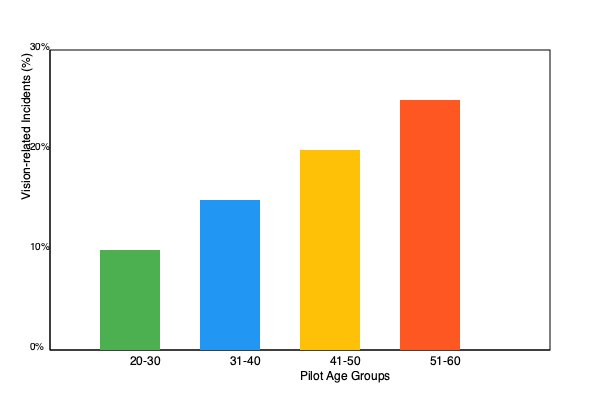Based on the bar graph showing the relationship between pilot age groups and vision-related incidents, which age group should be considered for higher insurance premiums or more frequent vision assessments? Provide a brief justification for your answer. To answer this question, we need to analyze the bar graph and interpret the data:

1. The graph shows four age groups of pilots: 20-30, 31-40, 41-50, and 51-60.
2. The y-axis represents the percentage of vision-related incidents.
3. We can observe that the percentage of vision-related incidents increases with age:
   - 20-30 age group: approximately 10%
   - 31-40 age group: approximately 15%
   - 41-50 age group: approximately 20%
   - 51-60 age group: approximately 25%
4. The 51-60 age group has the highest percentage of vision-related incidents at about 25%.
5. As an insurance professional, we should consider the group with the highest risk for higher premiums or more frequent assessments.
6. The data suggests that older pilots, particularly those in the 51-60 age group, are more prone to vision-related incidents.
7. This increased risk justifies considering higher insurance premiums or more frequent vision assessments for this age group.

Therefore, the 51-60 age group should be considered for higher insurance premiums or more frequent vision assessments due to their higher percentage of vision-related incidents.
Answer: 51-60 age group; highest risk of vision-related incidents (25%). 